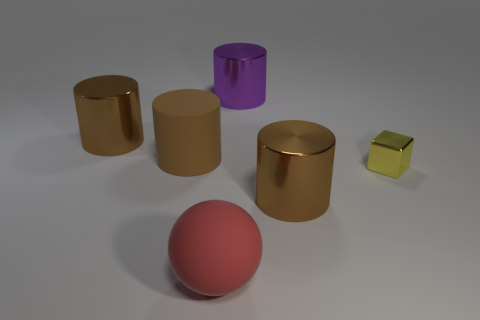Are there an equal number of big red balls right of the ball and large blue things?
Your answer should be very brief. Yes. What number of objects have the same size as the purple shiny cylinder?
Keep it short and to the point. 4. There is a brown matte object; what number of large metal things are to the right of it?
Your answer should be compact. 2. The big object in front of the big shiny thing on the right side of the purple cylinder is made of what material?
Your answer should be compact. Rubber. Is there another big cylinder that has the same color as the big rubber cylinder?
Offer a terse response. Yes. What is the size of the yellow block that is made of the same material as the large purple cylinder?
Keep it short and to the point. Small. Are there any other things that have the same color as the big rubber cylinder?
Offer a terse response. Yes. There is a large metal thing left of the large red object; what color is it?
Keep it short and to the point. Brown. There is a big thing behind the metallic thing that is to the left of the brown matte cylinder; is there a shiny cylinder to the right of it?
Offer a very short reply. Yes. Is the number of large rubber things that are left of the big ball greater than the number of large red shiny cylinders?
Your answer should be compact. Yes. 